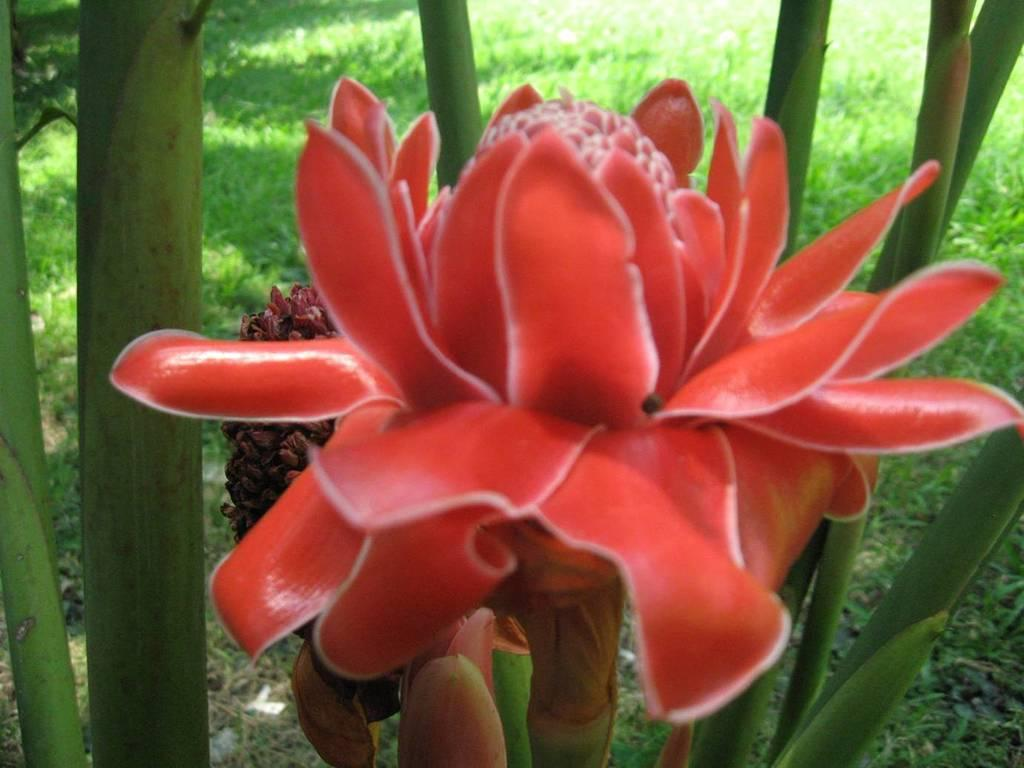What is the main subject of the image? The main subject of the image is a flower. Can you describe the color of the flower? The flower is red. What type of vegetation is visible in the image besides the flower? There is grass in the image. What type of coach can be seen in the image? There is no coach present in the image; it features a red flower and grass. What type of education is being provided in the image? There is no educational activity depicted in the image; it features a red flower and grass. 